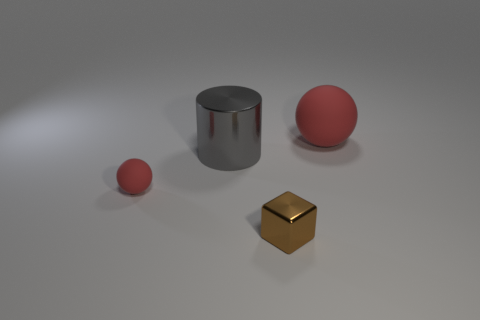Add 3 tiny metal blocks. How many objects exist? 7 Subtract all blue blocks. Subtract all gray balls. How many blocks are left? 1 Subtract all gray cylinders. How many purple spheres are left? 0 Subtract all red things. Subtract all balls. How many objects are left? 0 Add 3 matte objects. How many matte objects are left? 5 Add 3 small yellow objects. How many small yellow objects exist? 3 Subtract 0 brown cylinders. How many objects are left? 4 Subtract 1 blocks. How many blocks are left? 0 